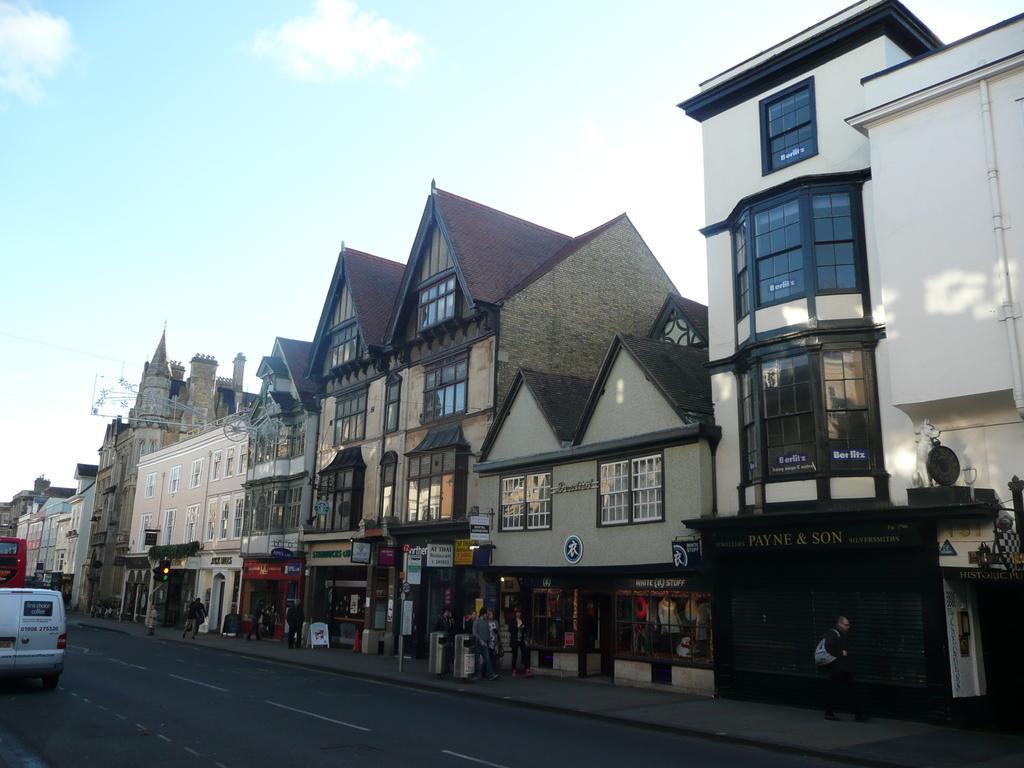Describe this image in one or two sentences. In this picture we can see a view of the buildings with roof tiles. In the bottom we can see some shops. In the front bottom side there is a road and white color van moving on the road. On the top there is a sky and clouds. 